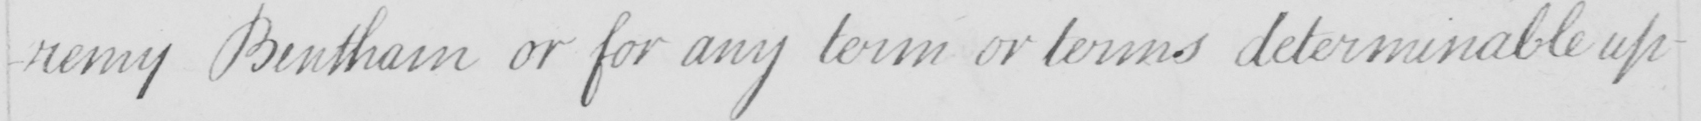Can you read and transcribe this handwriting? -remy Bentham or for any term or terms determinable up- 